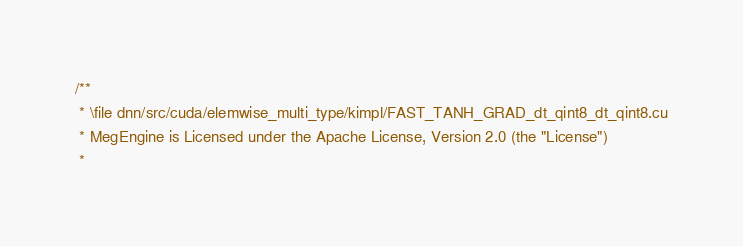Convert code to text. <code><loc_0><loc_0><loc_500><loc_500><_Cuda_>/**
 * \file dnn/src/cuda/elemwise_multi_type/kimpl/FAST_TANH_GRAD_dt_qint8_dt_qint8.cu
 * MegEngine is Licensed under the Apache License, Version 2.0 (the "License")
 *</code> 